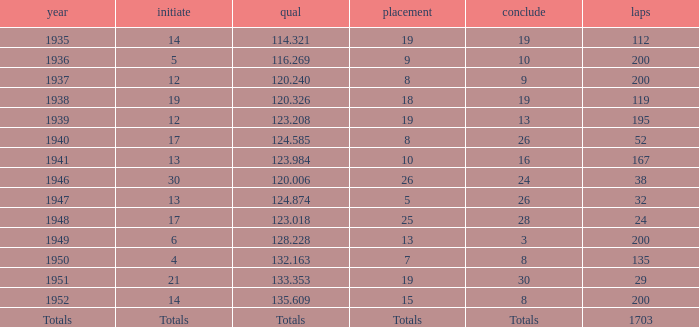With a Rank of 19, and a Start of 14, what was the finish? 19.0. 